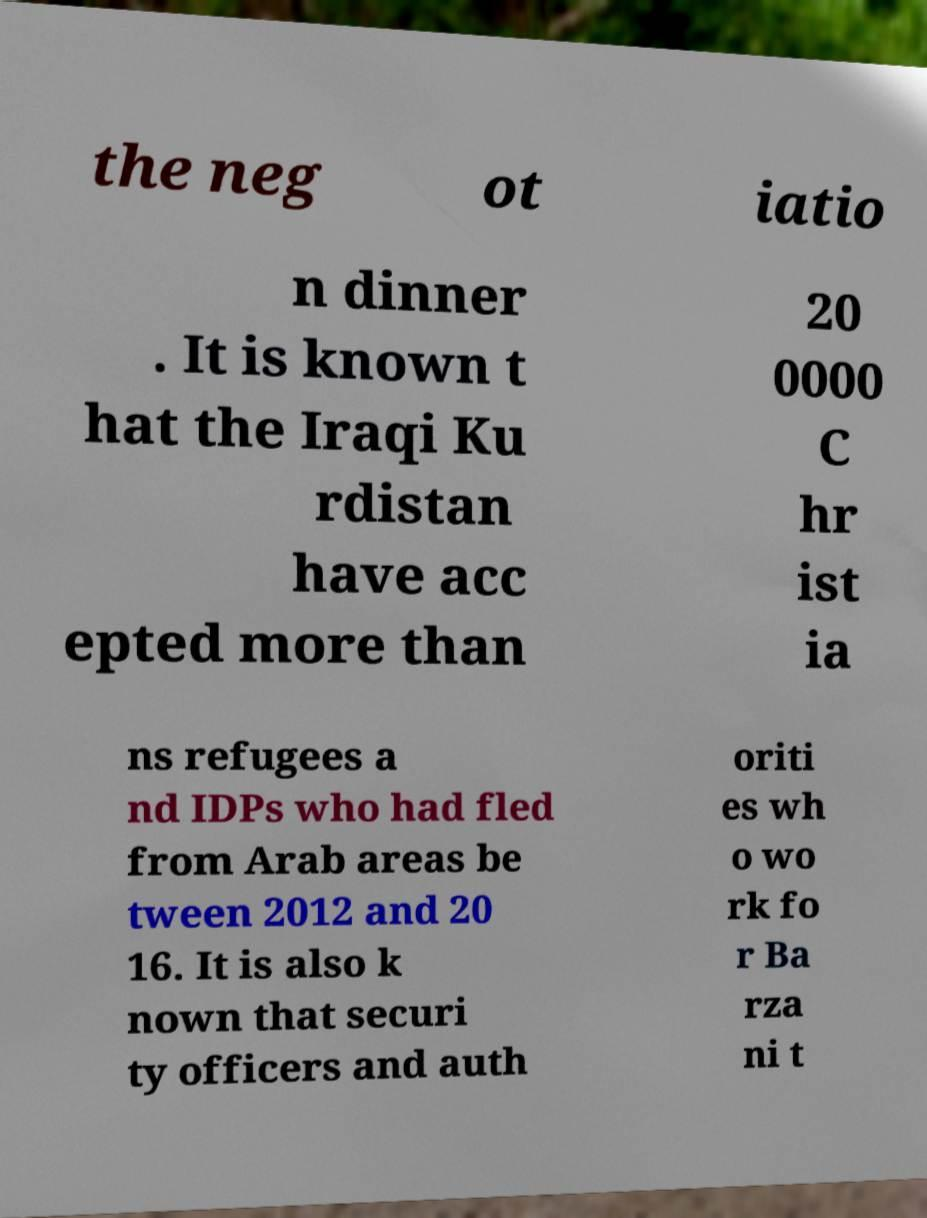For documentation purposes, I need the text within this image transcribed. Could you provide that? the neg ot iatio n dinner . It is known t hat the Iraqi Ku rdistan have acc epted more than 20 0000 C hr ist ia ns refugees a nd IDPs who had fled from Arab areas be tween 2012 and 20 16. It is also k nown that securi ty officers and auth oriti es wh o wo rk fo r Ba rza ni t 